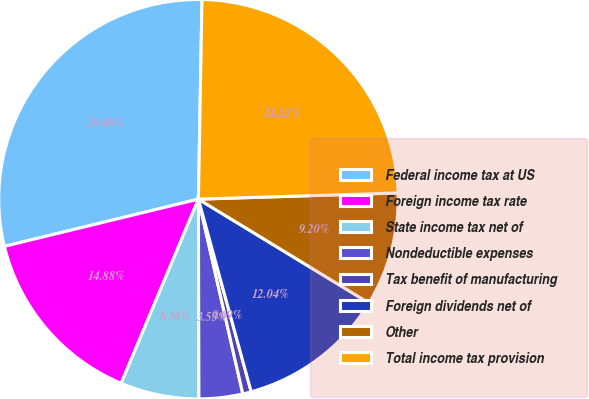<chart> <loc_0><loc_0><loc_500><loc_500><pie_chart><fcel>Federal income tax at US<fcel>Foreign income tax rate<fcel>State income tax net of<fcel>Nondeductible expenses<fcel>Tax benefit of manufacturing<fcel>Foreign dividends net of<fcel>Other<fcel>Total income tax provision<nl><fcel>29.08%<fcel>14.88%<fcel>6.36%<fcel>3.53%<fcel>0.69%<fcel>12.04%<fcel>9.2%<fcel>24.22%<nl></chart> 